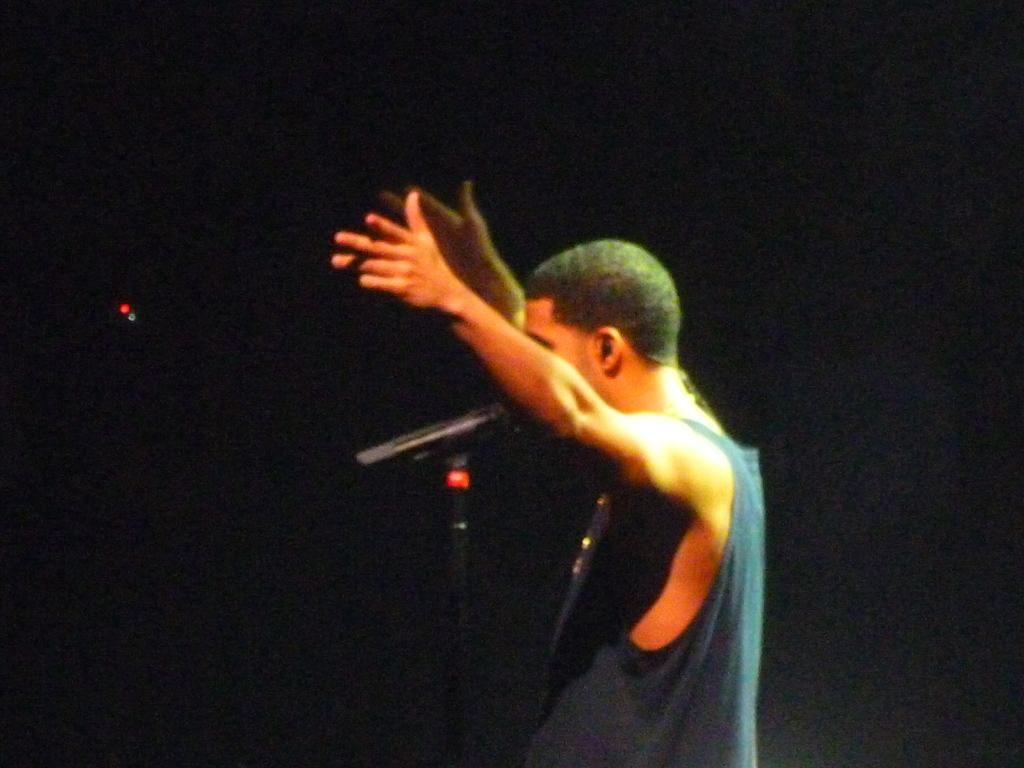Who is present in the image? There is a man in the image. What is the man wearing? The man is wearing a t-shirt. In which direction is the man facing? The man is standing facing towards the left side. What is the man doing with his hands? The man is raising his hands up. What object is in front of the man? There is a microphone stand in front of the man. What can be observed about the background of the image? The background of the image is dark. What type of jeans is the man wearing in the image? The provided facts do not mention the man wearing jeans; he is wearing a t-shirt. Is there a party happening in the image? There is no information in the image or the provided facts to suggest that a party is taking place. 